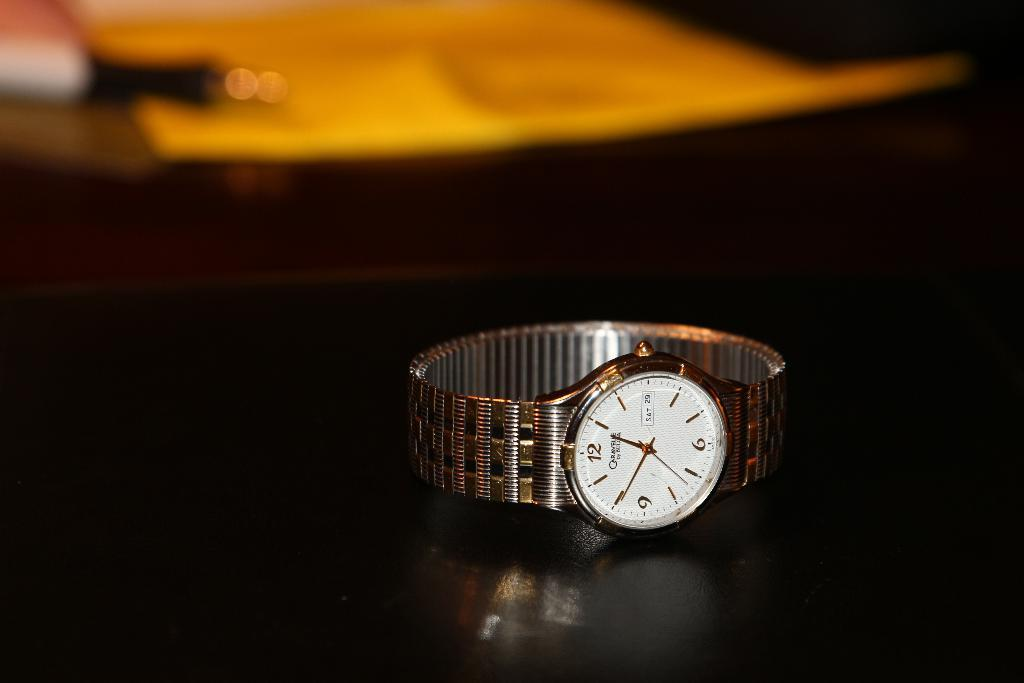<image>
Present a compact description of the photo's key features. A wrist watch on a table shows the date is Saturday the 29th. 